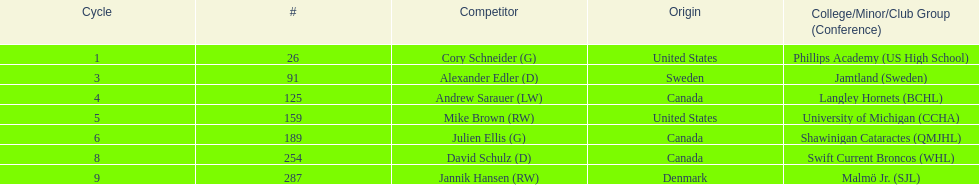Which competitors are not danish? Cory Schneider (G), Alexander Edler (D), Andrew Sarauer (LW), Mike Brown (RW), Julien Ellis (G), David Schulz (D). 